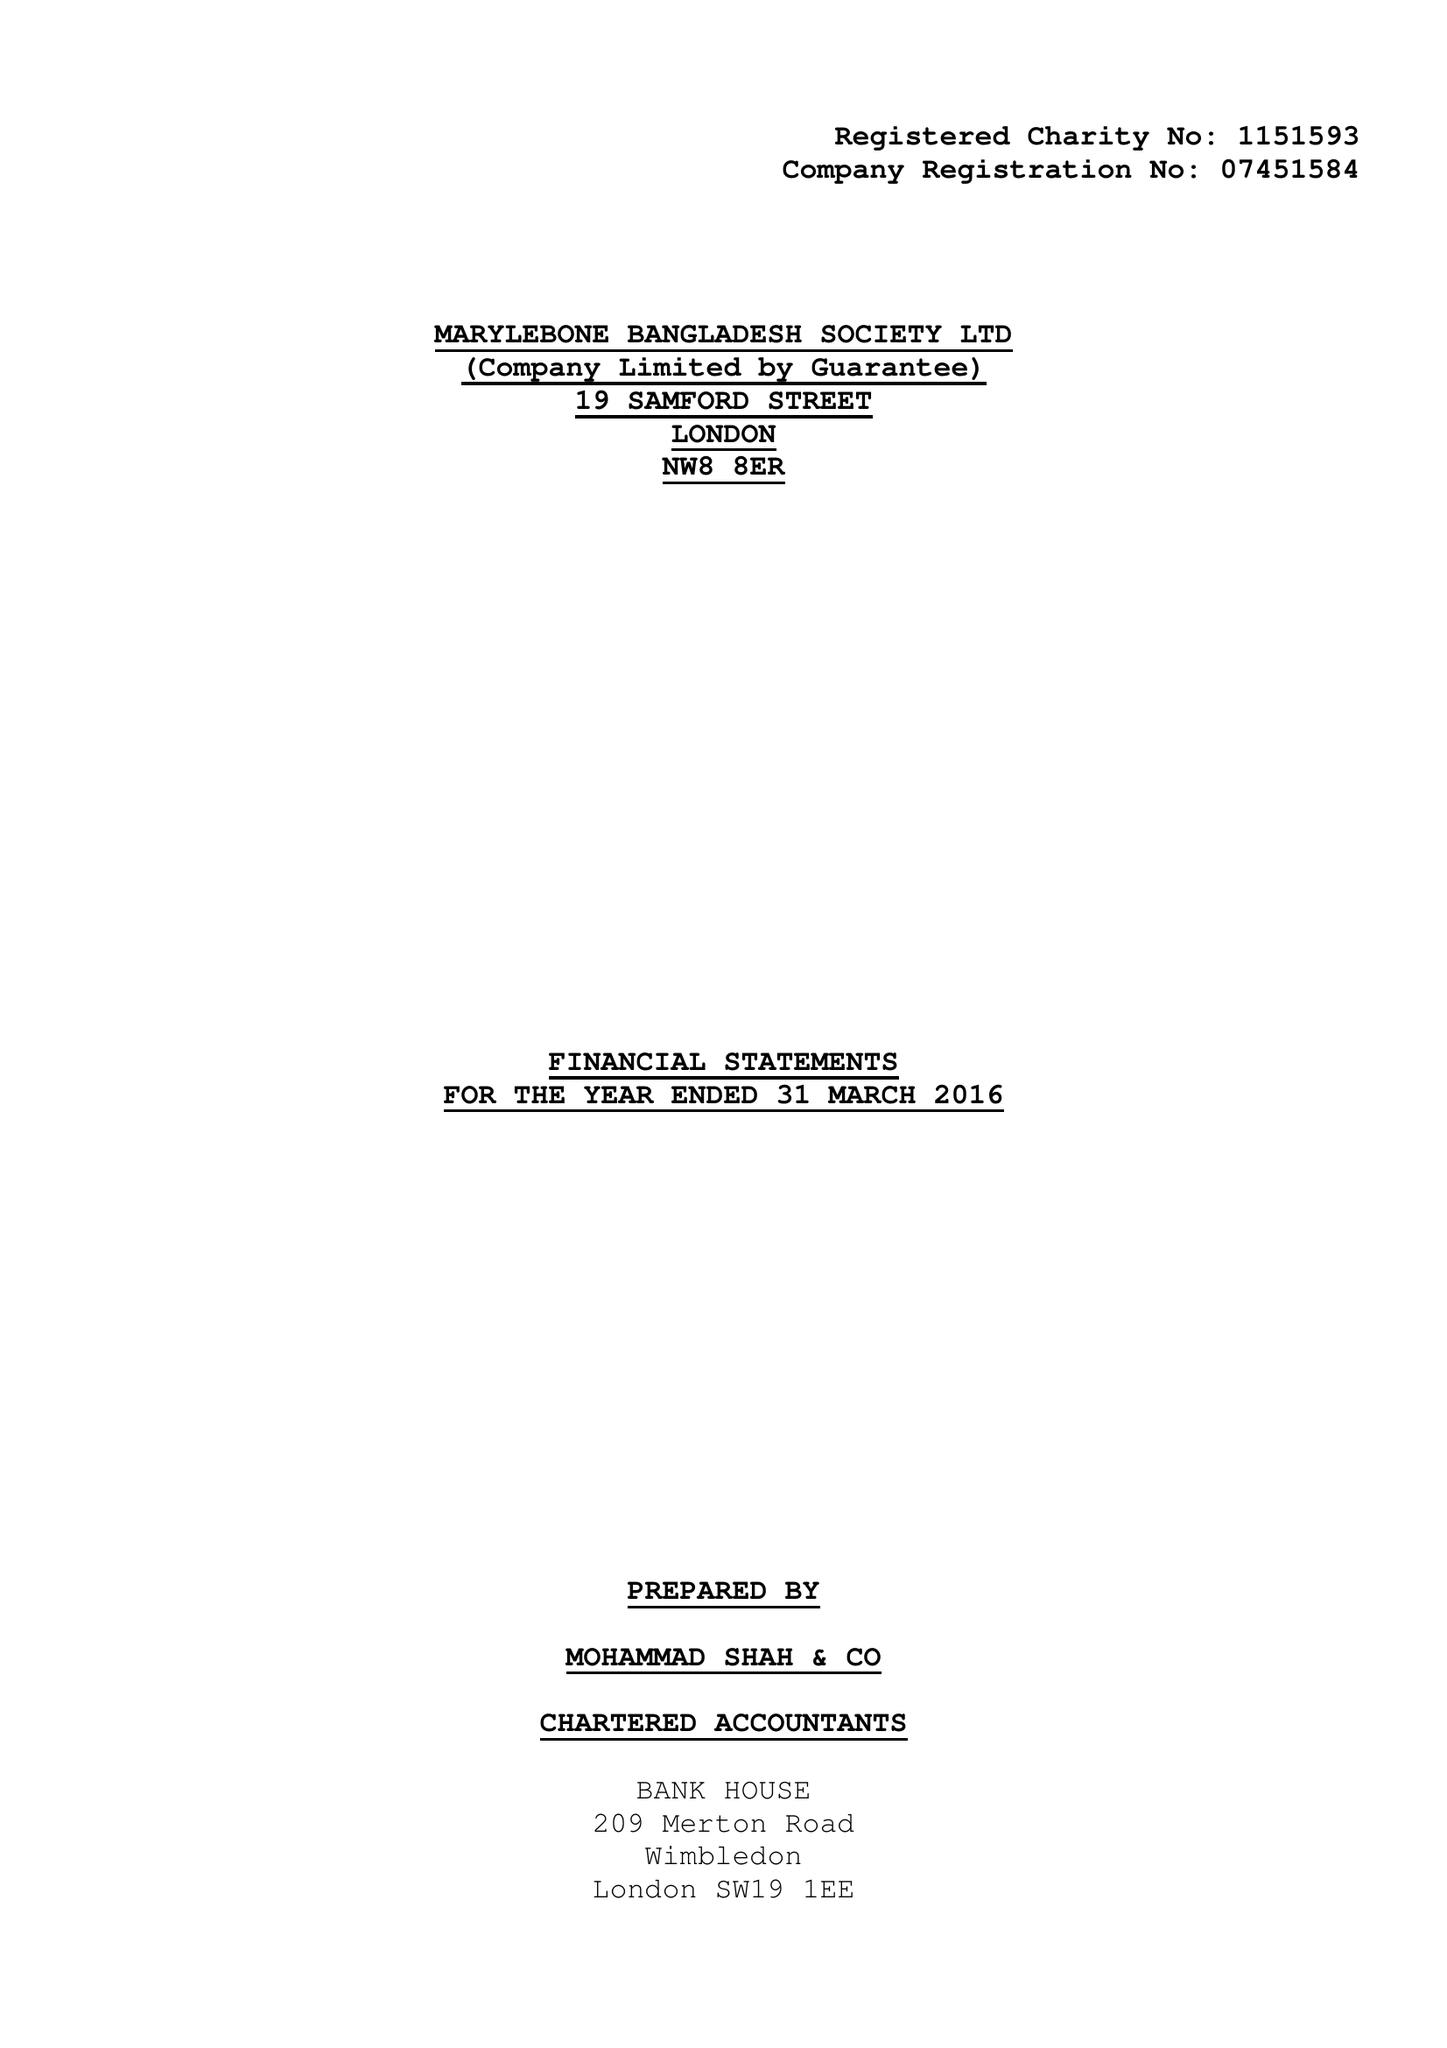What is the value for the income_annually_in_british_pounds?
Answer the question using a single word or phrase. 180230.00 